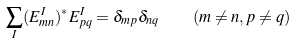<formula> <loc_0><loc_0><loc_500><loc_500>\sum _ { I } ( E _ { m n } ^ { I } ) ^ { * } E _ { p q } ^ { I } = \delta _ { m p } \delta _ { n q } \quad ( m \ne n , p \ne q )</formula> 